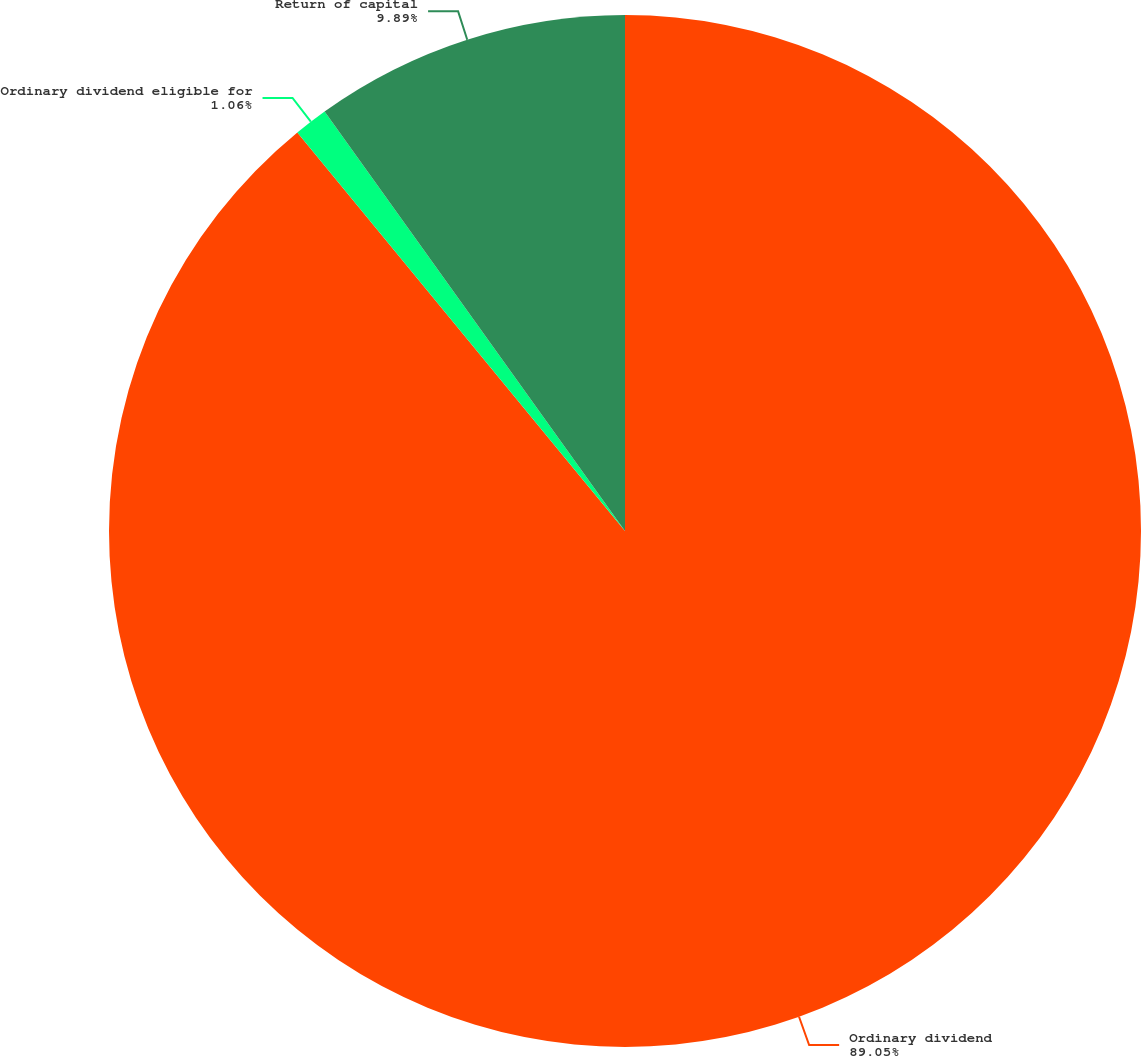Convert chart to OTSL. <chart><loc_0><loc_0><loc_500><loc_500><pie_chart><fcel>Ordinary dividend<fcel>Ordinary dividend eligible for<fcel>Return of capital<nl><fcel>89.05%<fcel>1.06%<fcel>9.89%<nl></chart> 